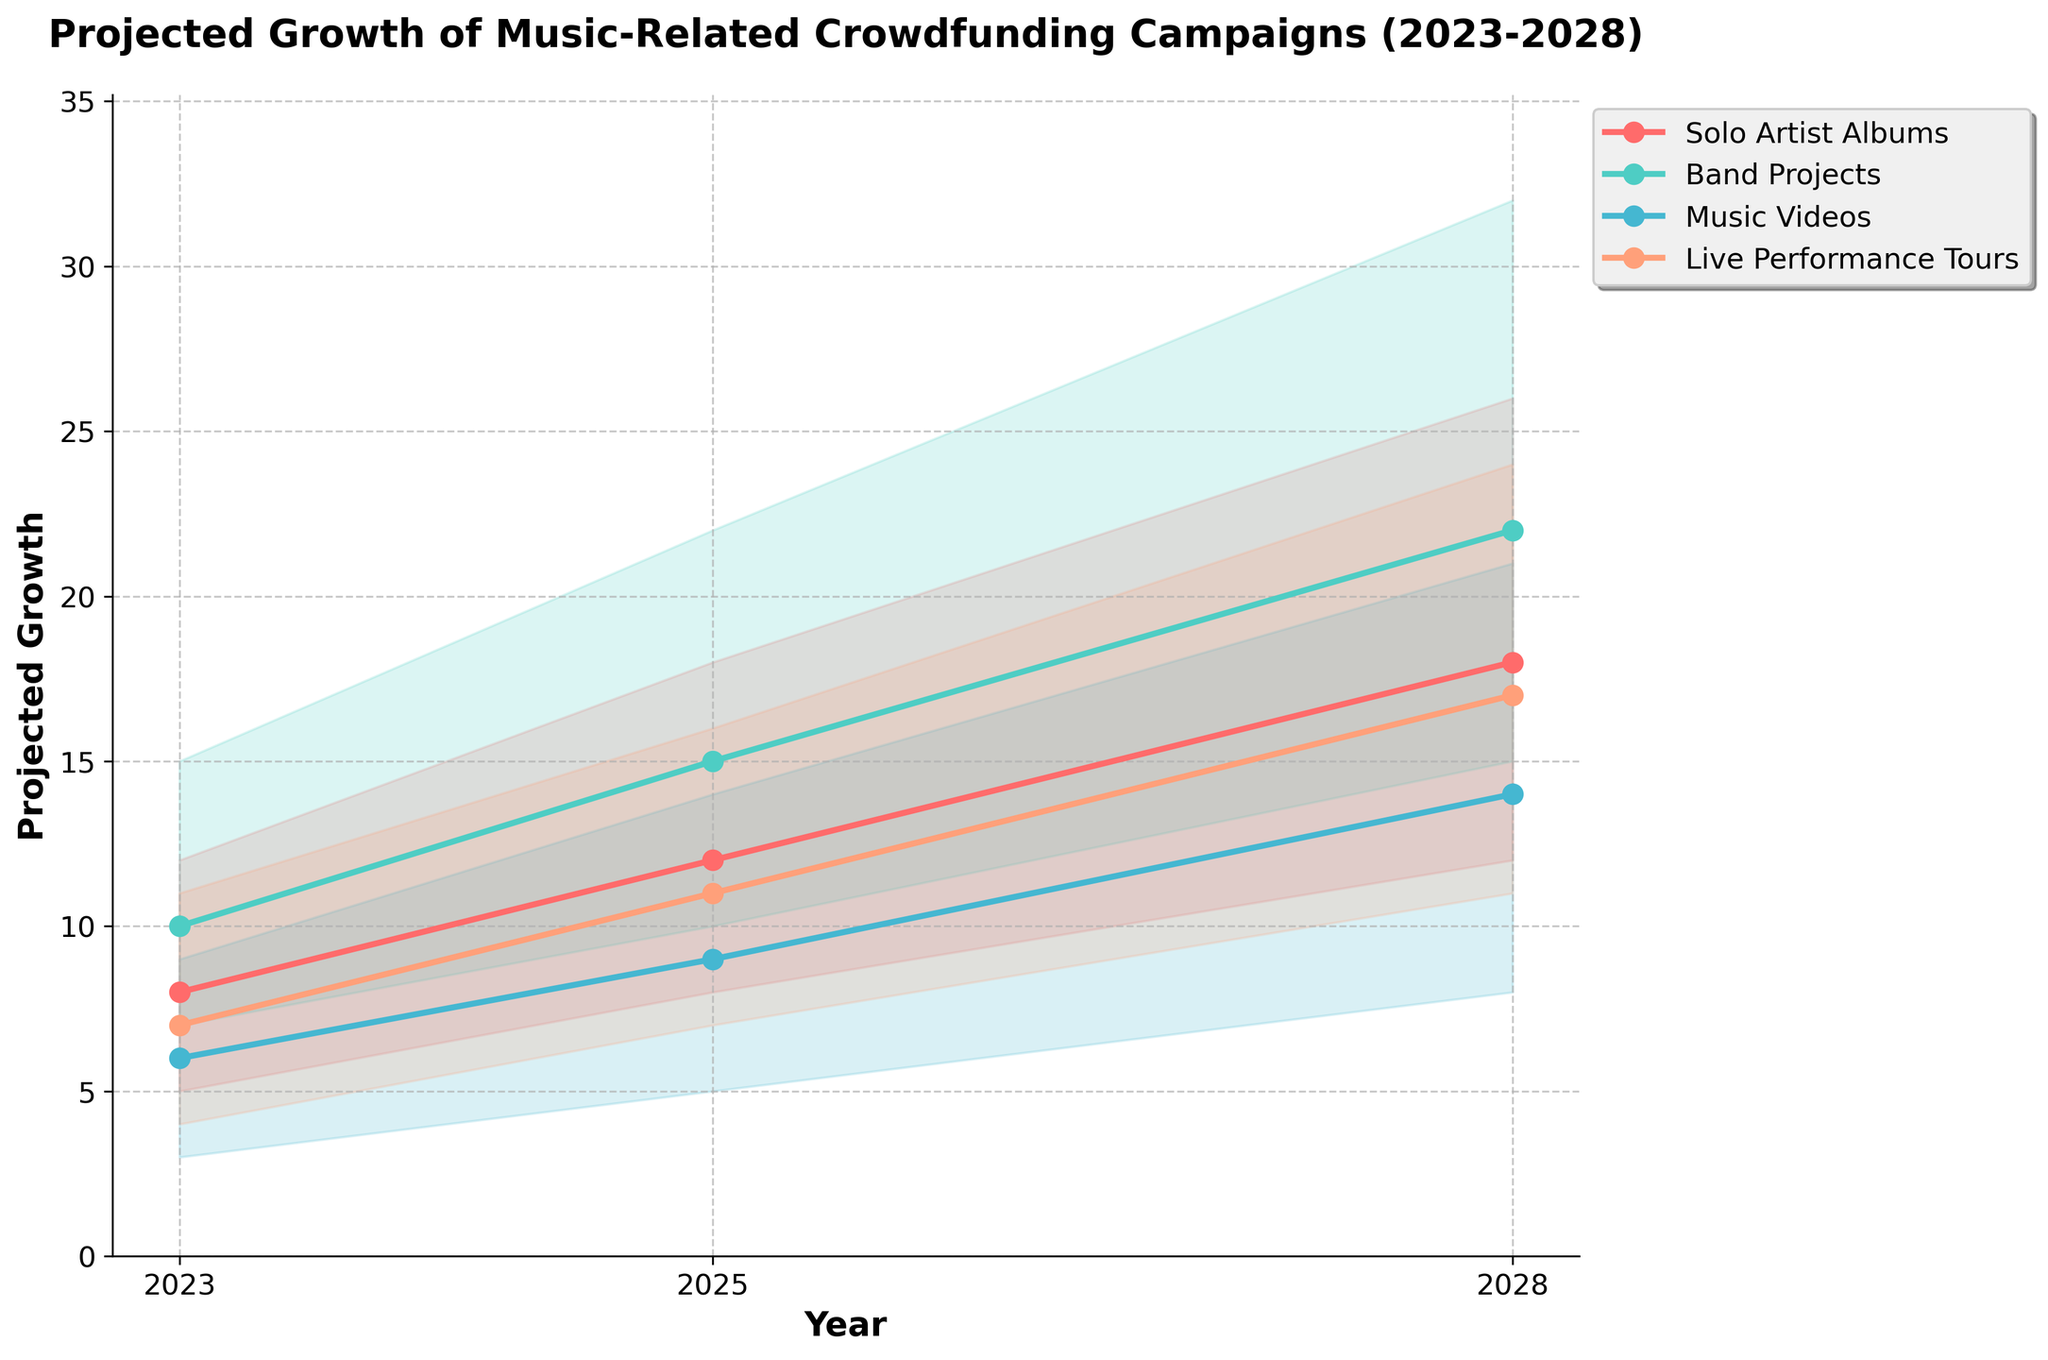What's the title of the chart? The chart's title is located at the top and provides a summary of the visualized data.
Answer: Projected Growth of Music-Related Crowdfunding Campaigns (2023-2028) What is the highest projected value for Solo Artist Albums in 2028? The highest value for Solo Artist Albums in 2028 is indicated by the top line in the fan chart for that year.
Answer: 26 Which project type has the highest medium estimate in 2025? The medium estimates are represented by the central lines for each project type. In 2025, compare these lines across all project types.
Answer: Band Projects What is the difference between the high estimates of Band Projects in 2028 and 2023? Subtract the high estimate of Band Projects in 2023 from the high estimate of Band Projects in 2028. 32 - 15 = 17.
Answer: 17 Between 2023 and 2028, which project type has the most significant increase in low estimates? Calculate the increase in low estimates for each project type by comparing the values in 2023 and 2028. For Solo Artist Albums: 12 - 5 = 7, for Band Projects: 15 - 7 = 8, for Music Videos: 8 - 3 = 5, for Live Performance Tours: 11 - 4 = 7. The Band Projects have the highest increase.
Answer: Band Projects How many project types are depicted in the chart? Count the distinct project types shown by unique lines and filled areas in the chart.
Answer: 4 Which project type shows the smallest range of estimates in 2023? Determine the range by subtracting the low estimate from the high estimate for each project type in 2023. For Solo Artist Albums: 12 - 5 = 7, for Band Projects: 15 - 7 = 8, for Music Videos: 9 - 3 = 6, for Live Performance Tours: 11 - 4 = 7. The smallest range is for Music Videos.
Answer: Music Videos What are the colors used for each project type? Identify the distinct colors used for the lines and filled areas corresponding to each project type.
Answer: Solo Artist Albums: red, Band Projects: teal, Music Videos: aqua, Live Performance Tours: orange Which project type has the greatest projected growth from 2023 to 2025 in terms of medium estimates? Calculate the growth by subtracting the 2023 medium estimate from the 2025 medium estimate for each project type. For Solo Artist Albums: 12 - 8 = 4, for Band Projects: 15 - 10 = 5, for Music Videos: 9 - 6 = 3, for Live Performance Tours: 11 - 7 = 4. The Band Projects have the greatest growth.
Answer: Band Projects 